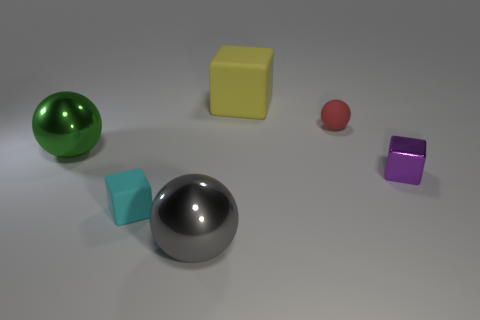If you had to guess, what might these objects be used for in a real-world setting? These objects might serve as models for visual demonstrations in a variety of contexts. For example, the various shapes and materials could be used for educational purposes, such as teaching geometry, material properties, or lighting effects in a physics or art class. Alternatively, they may be part of a display for product design visualization or used in a computer graphics testing environment. 